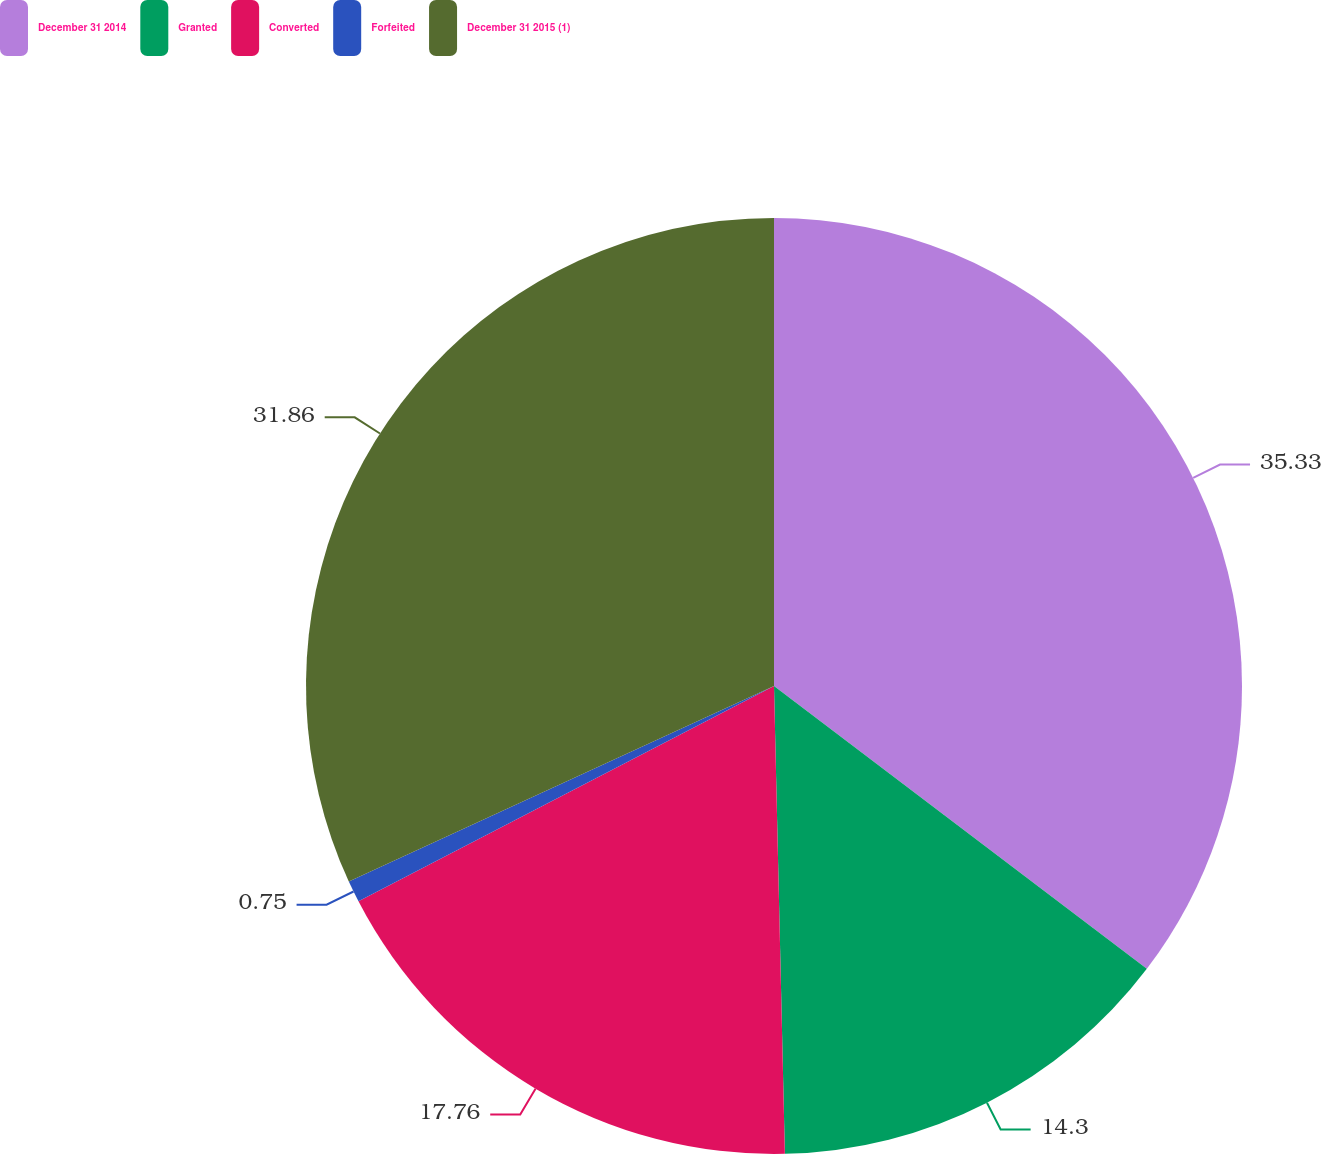Convert chart. <chart><loc_0><loc_0><loc_500><loc_500><pie_chart><fcel>December 31 2014<fcel>Granted<fcel>Converted<fcel>Forfeited<fcel>December 31 2015 (1)<nl><fcel>35.33%<fcel>14.3%<fcel>17.76%<fcel>0.75%<fcel>31.86%<nl></chart> 